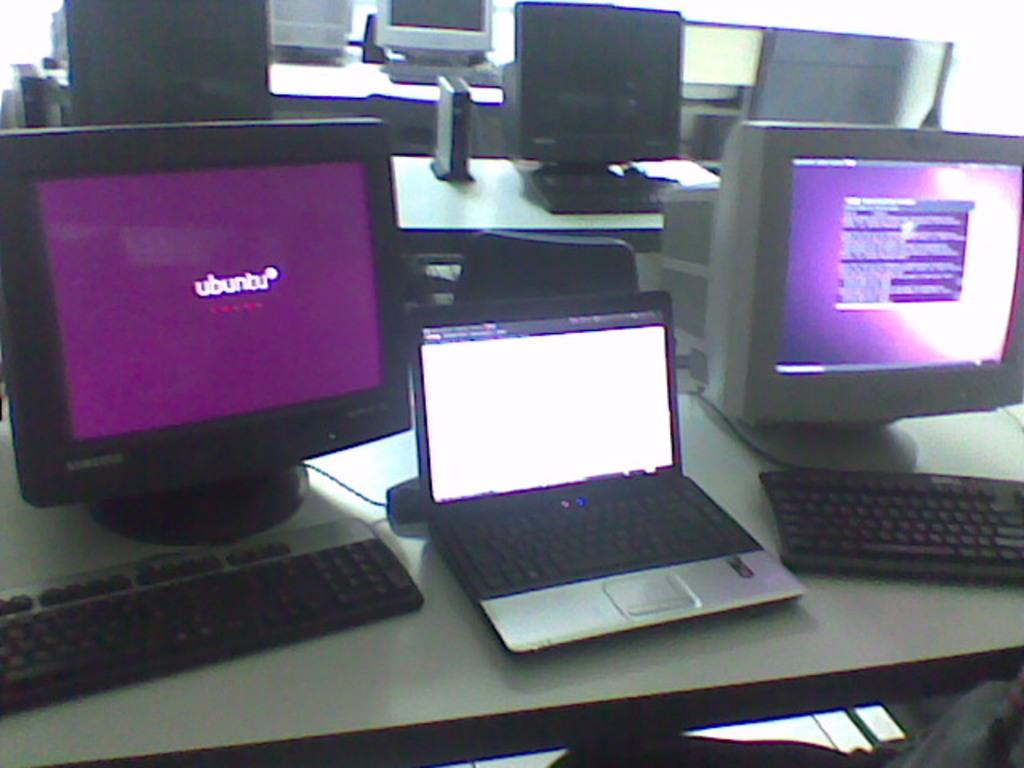<image>
Summarize the visual content of the image. The computer on the left is running the ubuntu operating system. 